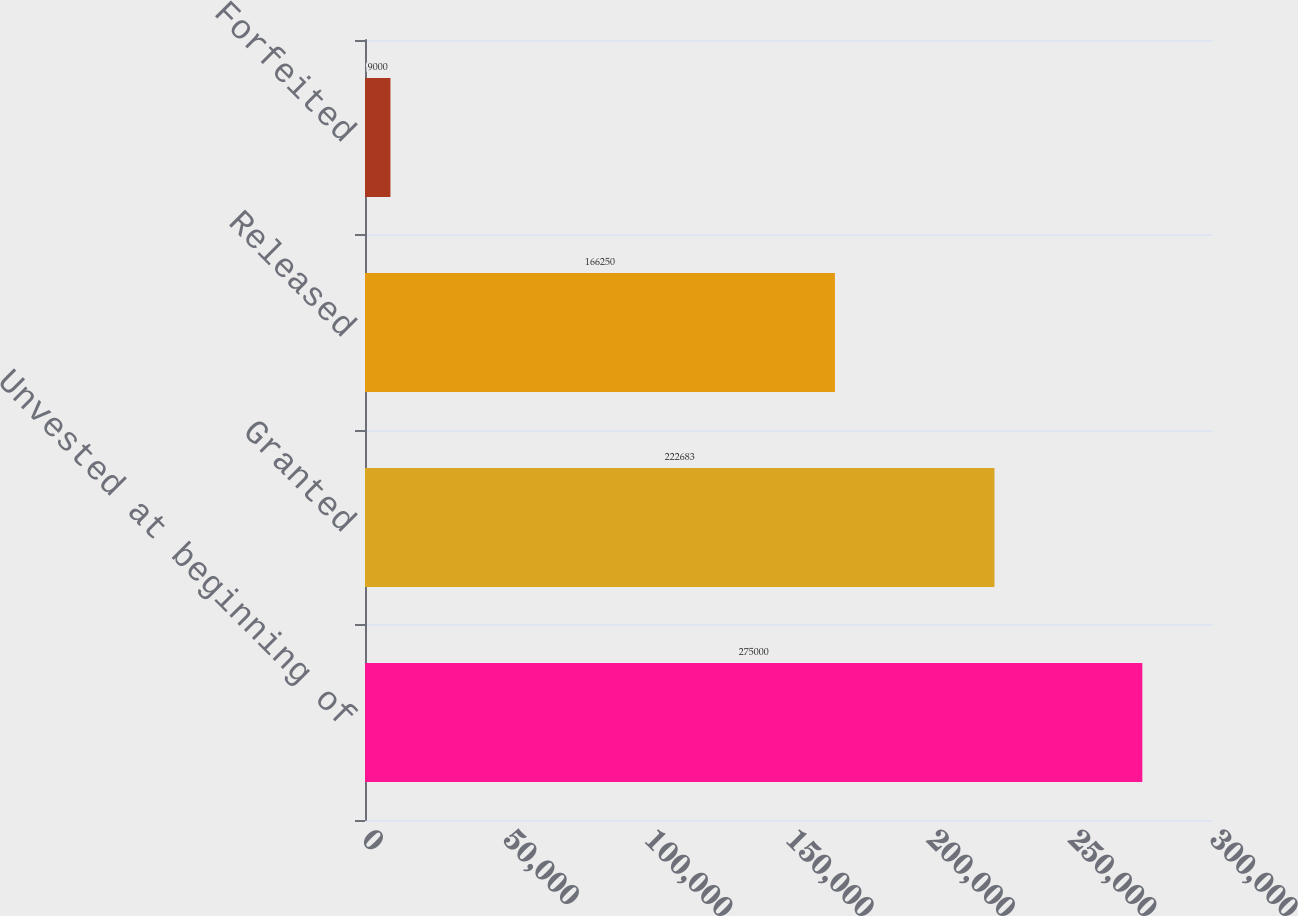Convert chart. <chart><loc_0><loc_0><loc_500><loc_500><bar_chart><fcel>Unvested at beginning of<fcel>Granted<fcel>Released<fcel>Forfeited<nl><fcel>275000<fcel>222683<fcel>166250<fcel>9000<nl></chart> 